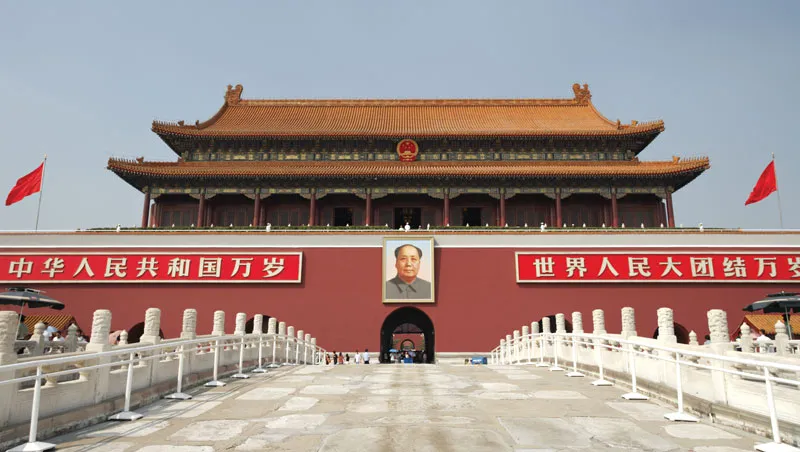What do you see happening in this image?
 The image captures the iconic Tiananmen Gate, the grand entrance to the Forbidden City in Beijing, China. The gate is a magnificent structure, painted in a vibrant shade of red that is characteristic of traditional Chinese architecture. The golden roof of the gate gleams under the sky, adding to its regal appearance. 

In the center of the gate, a large portrait of Mao Zedong, the founding father of the People's Republic of China, is prominently displayed. This portrait is a significant symbol, representing an important era in China's history. 

On either side of the gate, two red flags flutter in the breeze, their bright color matching the gate and adding a sense of symmetry to the scene. The gate is encircled by a white stone balustrade, providing a stark contrast to the red of the gate and flags. 

The image is taken from a low angle, which emphasizes the imposing size and grandeur of the gate. The words "天安门广场" can be seen, indicating that this is Tiananmen Square, one of the most famous landmarks in the world. The perspective of the image invites viewers to feel as if they are standing right there, looking up at this historic monument. 